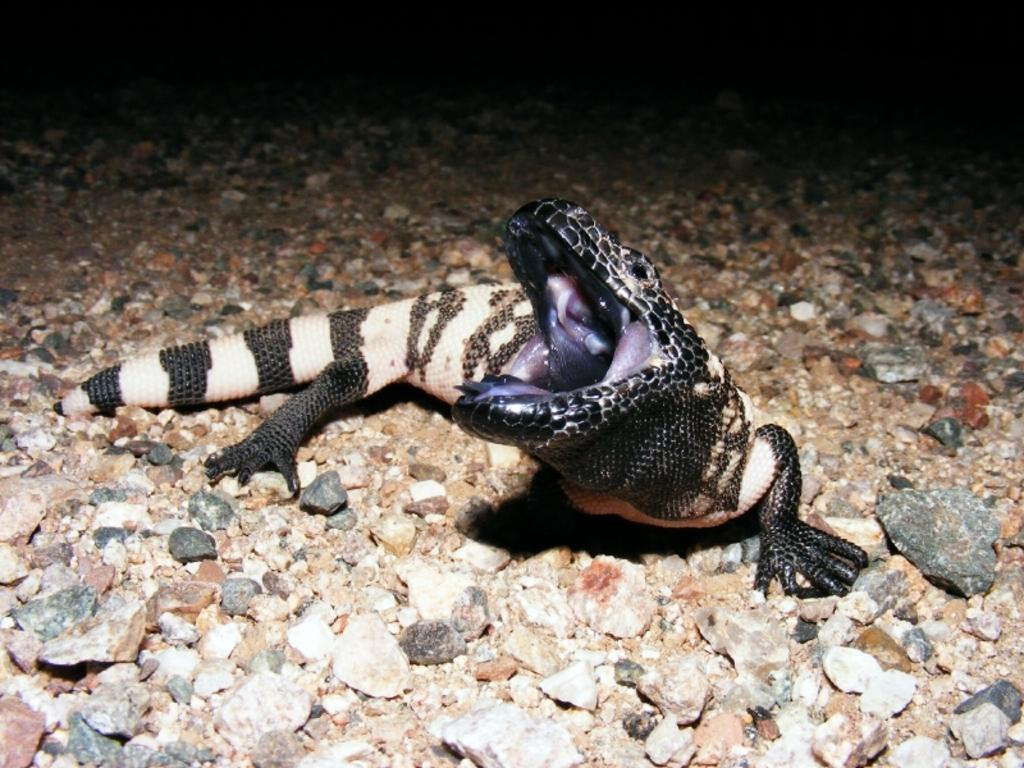What type of animal is on the ground in the image? There is a reptile on the ground in the image. What else can be seen on the ground in the image? There are stones on the ground in the image. What type of popcorn is being served at the event in the image? There is no event or popcorn present in the image; it only features a reptile and stones on the ground. 